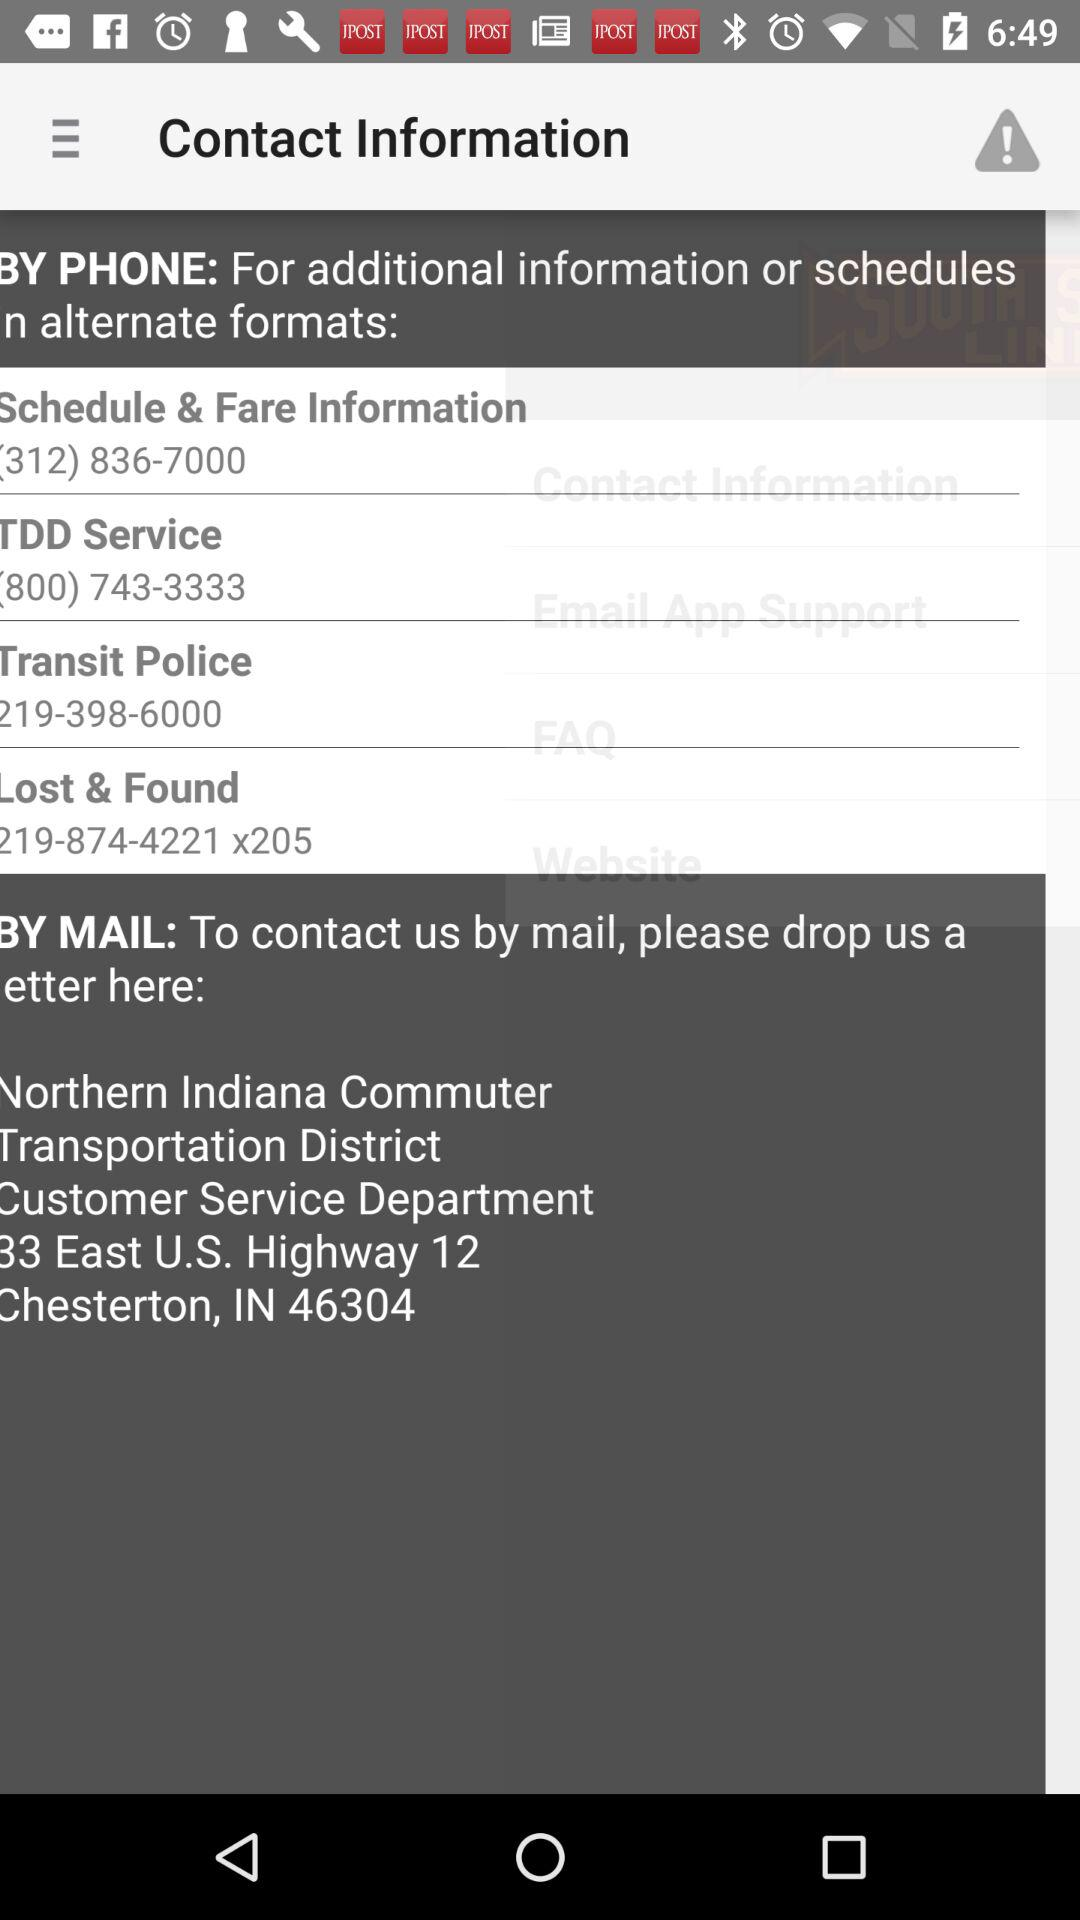What is the contact number for information about the schedule & fare information? The contact number is (312) 836-7000. 